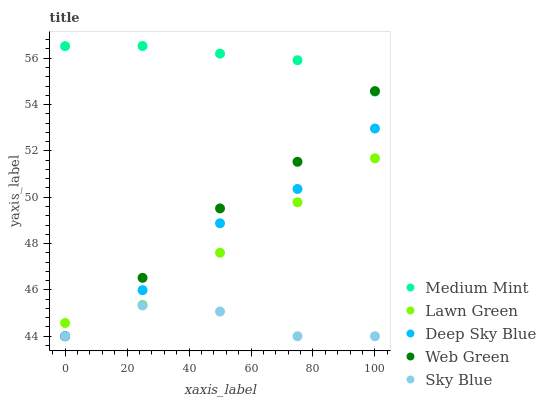Does Sky Blue have the minimum area under the curve?
Answer yes or no. Yes. Does Medium Mint have the maximum area under the curve?
Answer yes or no. Yes. Does Lawn Green have the minimum area under the curve?
Answer yes or no. No. Does Lawn Green have the maximum area under the curve?
Answer yes or no. No. Is Medium Mint the smoothest?
Answer yes or no. Yes. Is Sky Blue the roughest?
Answer yes or no. Yes. Is Lawn Green the smoothest?
Answer yes or no. No. Is Lawn Green the roughest?
Answer yes or no. No. Does Web Green have the lowest value?
Answer yes or no. Yes. Does Lawn Green have the lowest value?
Answer yes or no. No. Does Medium Mint have the highest value?
Answer yes or no. Yes. Does Lawn Green have the highest value?
Answer yes or no. No. Is Lawn Green less than Medium Mint?
Answer yes or no. Yes. Is Medium Mint greater than Deep Sky Blue?
Answer yes or no. Yes. Does Sky Blue intersect Web Green?
Answer yes or no. Yes. Is Sky Blue less than Web Green?
Answer yes or no. No. Is Sky Blue greater than Web Green?
Answer yes or no. No. Does Lawn Green intersect Medium Mint?
Answer yes or no. No. 